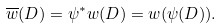<formula> <loc_0><loc_0><loc_500><loc_500>\overline { w } ( D ) = \psi ^ { * } w ( D ) = w ( \psi ( D ) ) .</formula> 